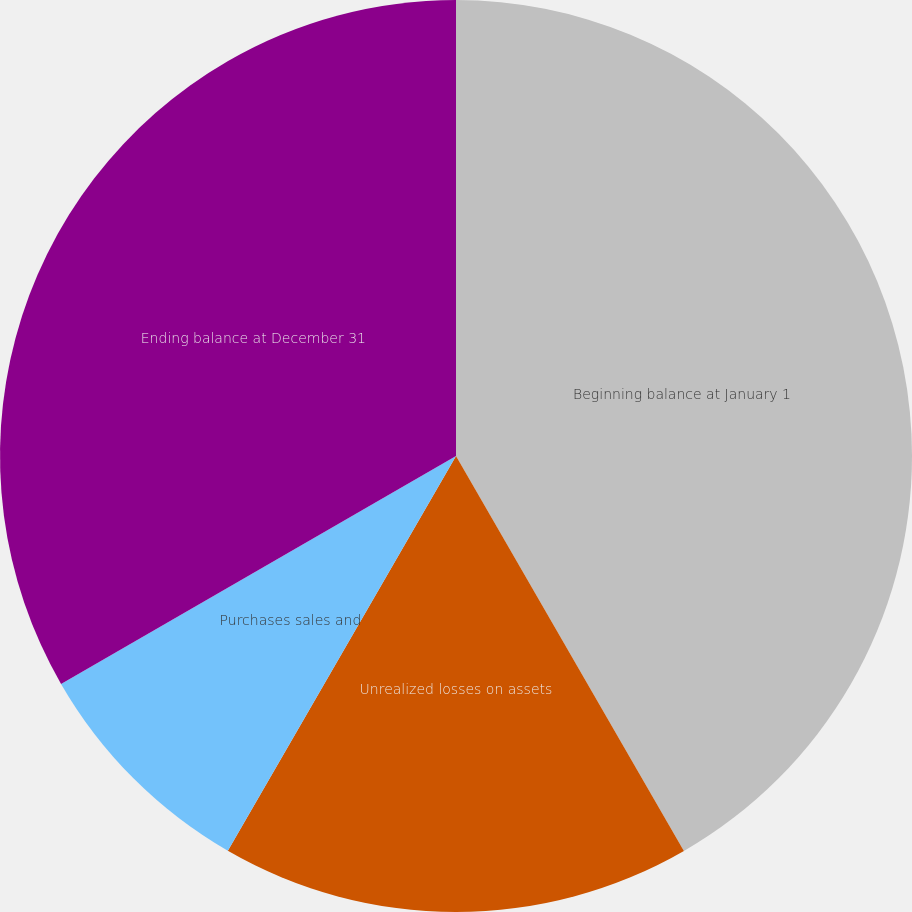<chart> <loc_0><loc_0><loc_500><loc_500><pie_chart><fcel>Beginning balance at January 1<fcel>Unrealized losses on assets<fcel>Purchases sales and<fcel>Ending balance at December 31<nl><fcel>41.67%<fcel>16.67%<fcel>8.33%<fcel>33.33%<nl></chart> 